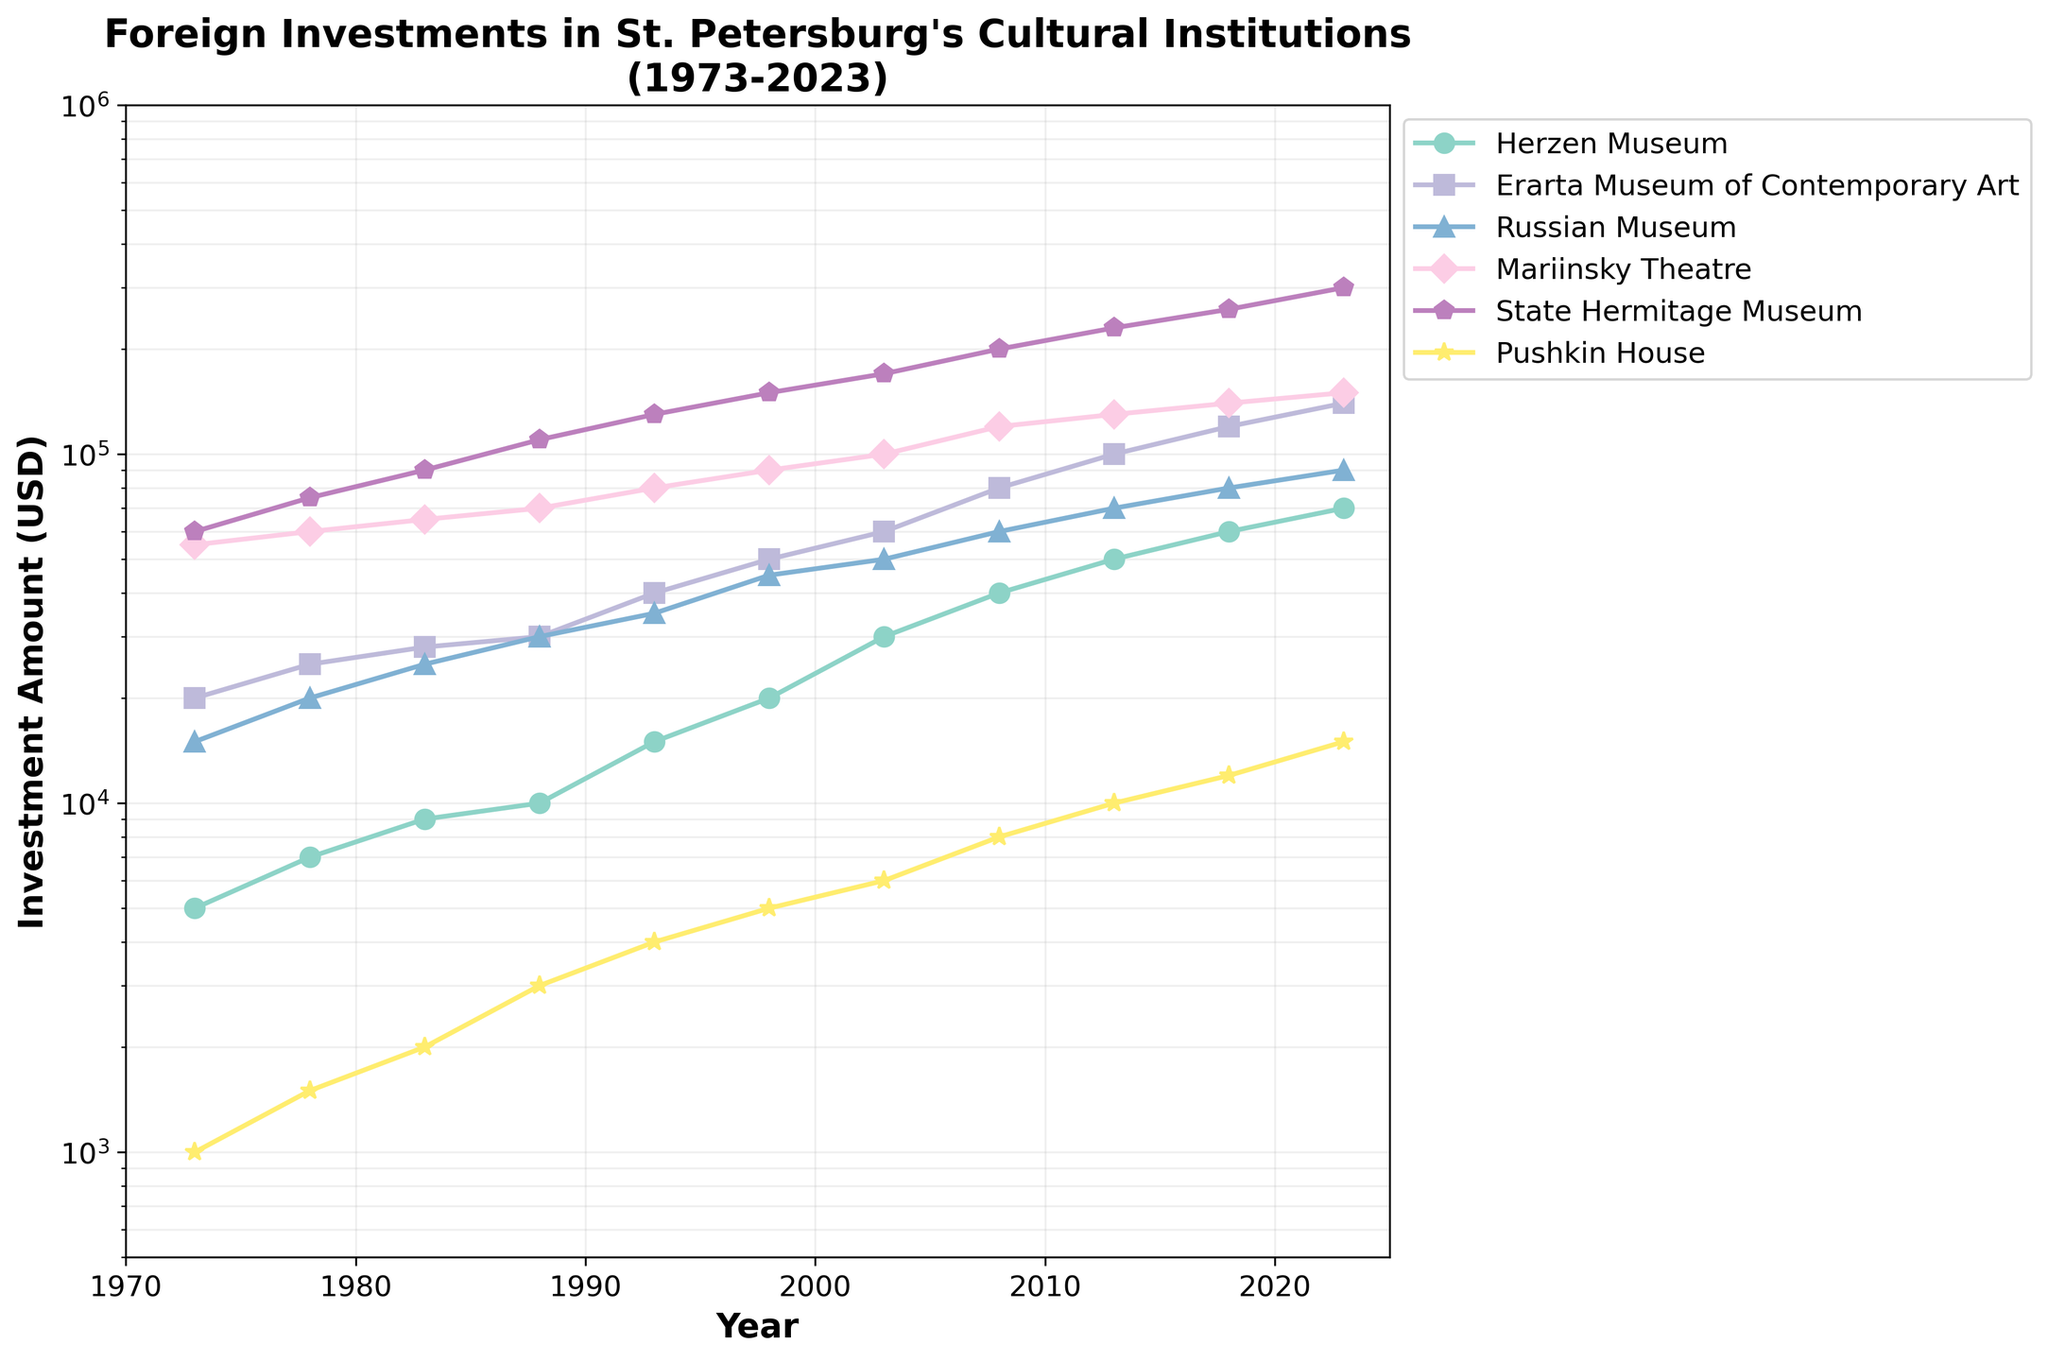what is the peak amount of investment received by the State Hermitage Museum? Locate the values plotted for the State Hermitage Museum. The peak value is in 2023, which is clearly indicated as the highest point for this museum on the log scale plot.
Answer: 300,000 USD Which cultural institution received the least foreign investment in 1973? Refer to the 1973 data points for all institutions and identify the lowest value. Herzen Museum had the lowest investment, as indicated by the data point positioned lowest on the vertical log scale axis.
Answer: Herzen Museum By how much did the foreign investment in the Mariinsky Theatre increase from 1973 to 2023? Look at the Mariinsky Theatre's investment values for 1973 and 2023. Subtract the value in 1973 from the value in 2023: 150,000 - 55,000 = 95,000 USD.
Answer: 95,000 USD Which institution showed a greater increase in investment from 1983 to 1988, Russian Museum or Pushkin House? Compare the increments for both: 
- Russian Museum: 30,000 - 25,000 = 5,000 USD
- Pushkin House: 3,000 - 2,000 = 1,000 USD
The Russian Museum had a larger increase.
Answer: Russian Museum From 1993 to 2003, which cultural institution saw the highest cumulative growth in foreign investments? Calculate the differences for each institution from 1993 to 2003:
- Herzen Museum: 30,000 - 15,000 = 15,000 USD
- Erarta Museum: 60,000 - 40,000 = 20,000 USD
- Russian Museum: 50,000 - 35,000 = 15,000 USD
- Mariinsky Theatre: 100,000 - 80,000 = 20,000 USD
- State Hermitage: 170,000 - 130,000 = 40,000 USD
- Pushkin House: 6,000 - 4,000 = 2,000 USD
The State Hermitage Museum saw the highest cumulative growth.
Answer: State Hermitage Museum What is the total foreign investment received by the Pushkin House from 1973 to 2023? Sum the values of the Pushkin House's investments over all years: 1,000 + 1,500 + 2,000 + 3,000 + 4,000 + 5,000 + 6,000 + 8,000 + 10,000 + 12,000 + 15,000 = 67,500 USD.
Answer: 67,500 USD Does any institution show a period of stagnation (no significant increase) in foreign investment? Analyze the trend for each institution and observe the periods where the investment amounts remain almost the same.
- Herzen Museum shows steady growth.
- Erarta Museum shows steady growth.
- Russian Museum shows steady growth.
- Mariinsky Theatre shows steady growth.
- State Hermitage Museum shows steady growth.
- Pushkin House shows slower initial growth but eventually increases steadily.
None of the institutions show a significant period of stagnation.
Answer: No 